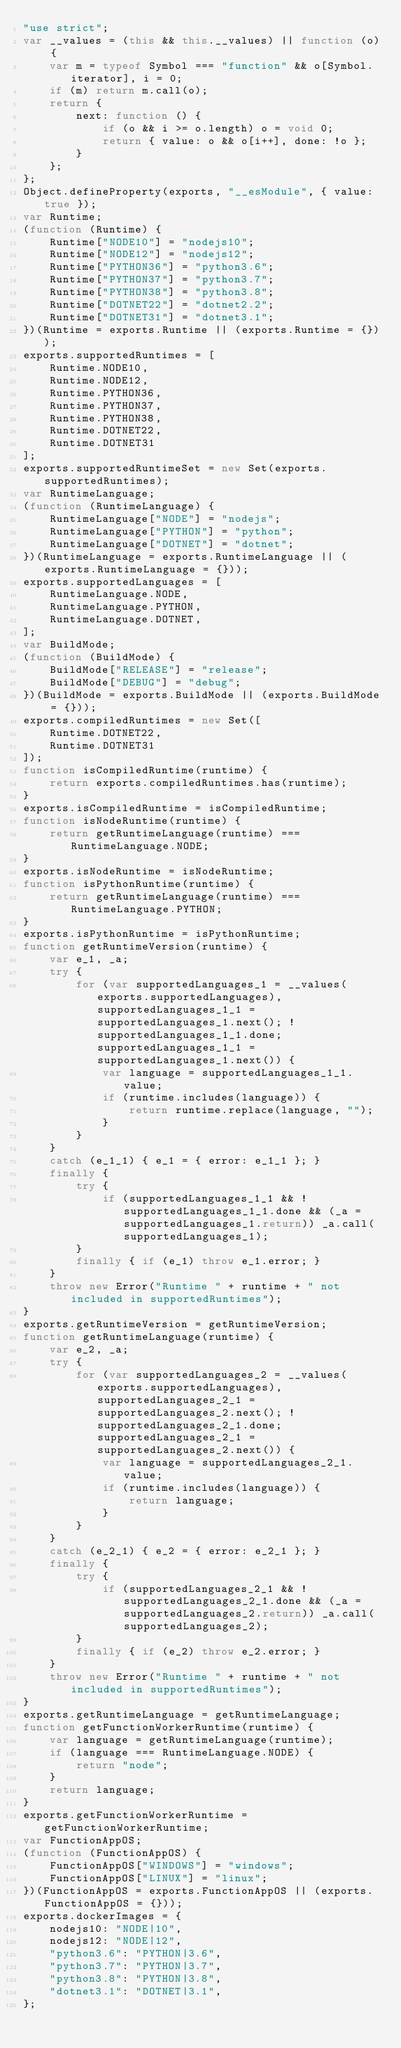<code> <loc_0><loc_0><loc_500><loc_500><_JavaScript_>"use strict";
var __values = (this && this.__values) || function (o) {
    var m = typeof Symbol === "function" && o[Symbol.iterator], i = 0;
    if (m) return m.call(o);
    return {
        next: function () {
            if (o && i >= o.length) o = void 0;
            return { value: o && o[i++], done: !o };
        }
    };
};
Object.defineProperty(exports, "__esModule", { value: true });
var Runtime;
(function (Runtime) {
    Runtime["NODE10"] = "nodejs10";
    Runtime["NODE12"] = "nodejs12";
    Runtime["PYTHON36"] = "python3.6";
    Runtime["PYTHON37"] = "python3.7";
    Runtime["PYTHON38"] = "python3.8";
    Runtime["DOTNET22"] = "dotnet2.2";
    Runtime["DOTNET31"] = "dotnet3.1";
})(Runtime = exports.Runtime || (exports.Runtime = {}));
exports.supportedRuntimes = [
    Runtime.NODE10,
    Runtime.NODE12,
    Runtime.PYTHON36,
    Runtime.PYTHON37,
    Runtime.PYTHON38,
    Runtime.DOTNET22,
    Runtime.DOTNET31
];
exports.supportedRuntimeSet = new Set(exports.supportedRuntimes);
var RuntimeLanguage;
(function (RuntimeLanguage) {
    RuntimeLanguage["NODE"] = "nodejs";
    RuntimeLanguage["PYTHON"] = "python";
    RuntimeLanguage["DOTNET"] = "dotnet";
})(RuntimeLanguage = exports.RuntimeLanguage || (exports.RuntimeLanguage = {}));
exports.supportedLanguages = [
    RuntimeLanguage.NODE,
    RuntimeLanguage.PYTHON,
    RuntimeLanguage.DOTNET,
];
var BuildMode;
(function (BuildMode) {
    BuildMode["RELEASE"] = "release";
    BuildMode["DEBUG"] = "debug";
})(BuildMode = exports.BuildMode || (exports.BuildMode = {}));
exports.compiledRuntimes = new Set([
    Runtime.DOTNET22,
    Runtime.DOTNET31
]);
function isCompiledRuntime(runtime) {
    return exports.compiledRuntimes.has(runtime);
}
exports.isCompiledRuntime = isCompiledRuntime;
function isNodeRuntime(runtime) {
    return getRuntimeLanguage(runtime) === RuntimeLanguage.NODE;
}
exports.isNodeRuntime = isNodeRuntime;
function isPythonRuntime(runtime) {
    return getRuntimeLanguage(runtime) === RuntimeLanguage.PYTHON;
}
exports.isPythonRuntime = isPythonRuntime;
function getRuntimeVersion(runtime) {
    var e_1, _a;
    try {
        for (var supportedLanguages_1 = __values(exports.supportedLanguages), supportedLanguages_1_1 = supportedLanguages_1.next(); !supportedLanguages_1_1.done; supportedLanguages_1_1 = supportedLanguages_1.next()) {
            var language = supportedLanguages_1_1.value;
            if (runtime.includes(language)) {
                return runtime.replace(language, "");
            }
        }
    }
    catch (e_1_1) { e_1 = { error: e_1_1 }; }
    finally {
        try {
            if (supportedLanguages_1_1 && !supportedLanguages_1_1.done && (_a = supportedLanguages_1.return)) _a.call(supportedLanguages_1);
        }
        finally { if (e_1) throw e_1.error; }
    }
    throw new Error("Runtime " + runtime + " not included in supportedRuntimes");
}
exports.getRuntimeVersion = getRuntimeVersion;
function getRuntimeLanguage(runtime) {
    var e_2, _a;
    try {
        for (var supportedLanguages_2 = __values(exports.supportedLanguages), supportedLanguages_2_1 = supportedLanguages_2.next(); !supportedLanguages_2_1.done; supportedLanguages_2_1 = supportedLanguages_2.next()) {
            var language = supportedLanguages_2_1.value;
            if (runtime.includes(language)) {
                return language;
            }
        }
    }
    catch (e_2_1) { e_2 = { error: e_2_1 }; }
    finally {
        try {
            if (supportedLanguages_2_1 && !supportedLanguages_2_1.done && (_a = supportedLanguages_2.return)) _a.call(supportedLanguages_2);
        }
        finally { if (e_2) throw e_2.error; }
    }
    throw new Error("Runtime " + runtime + " not included in supportedRuntimes");
}
exports.getRuntimeLanguage = getRuntimeLanguage;
function getFunctionWorkerRuntime(runtime) {
    var language = getRuntimeLanguage(runtime);
    if (language === RuntimeLanguage.NODE) {
        return "node";
    }
    return language;
}
exports.getFunctionWorkerRuntime = getFunctionWorkerRuntime;
var FunctionAppOS;
(function (FunctionAppOS) {
    FunctionAppOS["WINDOWS"] = "windows";
    FunctionAppOS["LINUX"] = "linux";
})(FunctionAppOS = exports.FunctionAppOS || (exports.FunctionAppOS = {}));
exports.dockerImages = {
    nodejs10: "NODE|10",
    nodejs12: "NODE|12",
    "python3.6": "PYTHON|3.6",
    "python3.7": "PYTHON|3.7",
    "python3.8": "PYTHON|3.8",
    "dotnet3.1": "DOTNET|3.1",
};
</code> 